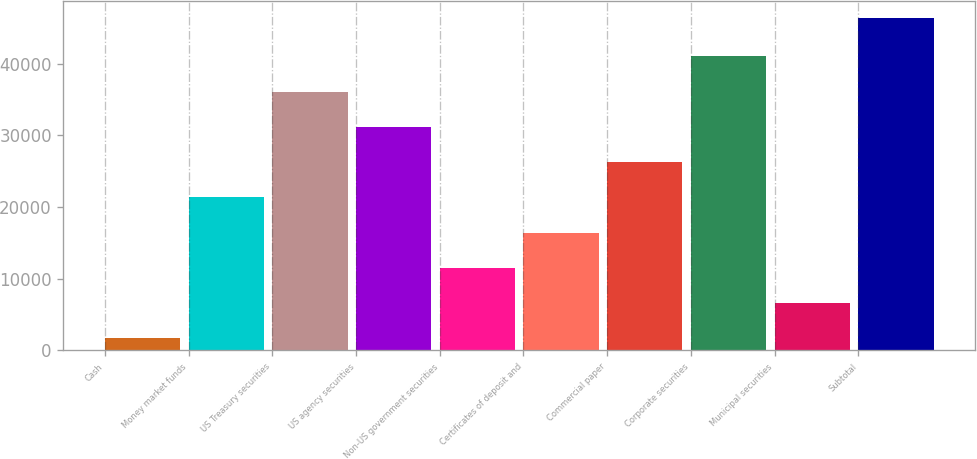<chart> <loc_0><loc_0><loc_500><loc_500><bar_chart><fcel>Cash<fcel>Money market funds<fcel>US Treasury securities<fcel>US agency securities<fcel>Non-US government securities<fcel>Certificates of deposit and<fcel>Commercial paper<fcel>Corporate securities<fcel>Municipal securities<fcel>Subtotal<nl><fcel>1690<fcel>21346.4<fcel>36088.7<fcel>31174.6<fcel>11518.2<fcel>16432.3<fcel>26260.5<fcel>41002.8<fcel>6604.1<fcel>46388<nl></chart> 